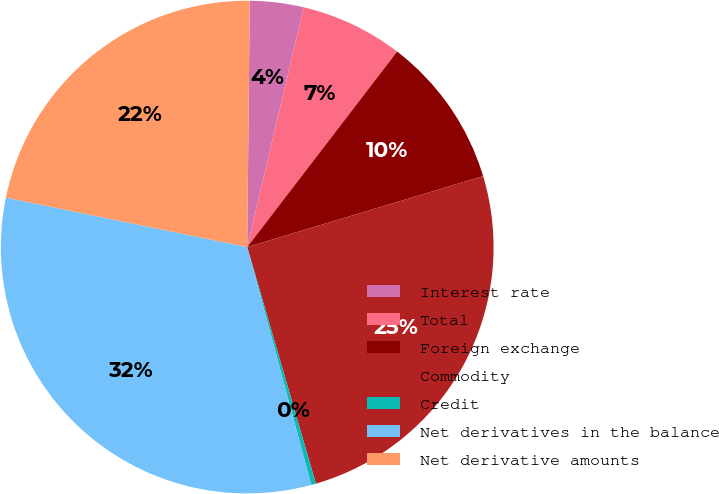<chart> <loc_0><loc_0><loc_500><loc_500><pie_chart><fcel>Interest rate<fcel>Total<fcel>Foreign exchange<fcel>Commodity<fcel>Credit<fcel>Net derivatives in the balance<fcel>Net derivative amounts<nl><fcel>3.52%<fcel>6.73%<fcel>9.94%<fcel>25.16%<fcel>0.31%<fcel>32.41%<fcel>21.95%<nl></chart> 